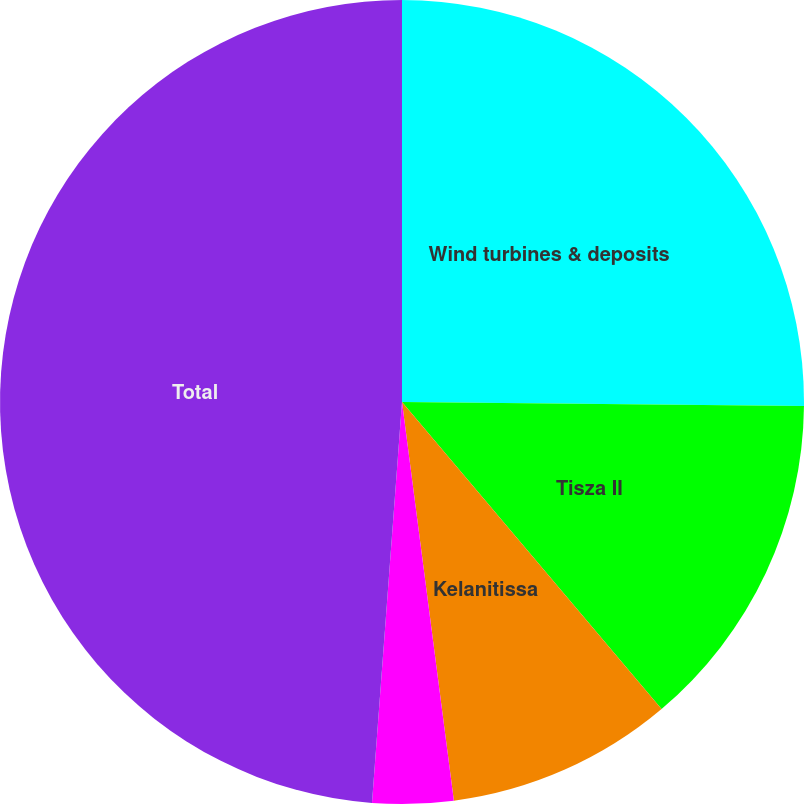Convert chart to OTSL. <chart><loc_0><loc_0><loc_500><loc_500><pie_chart><fcel>Wind turbines & deposits<fcel>Tisza II<fcel>Kelanitissa<fcel>Other<fcel>Total<nl><fcel>25.16%<fcel>13.67%<fcel>9.11%<fcel>3.25%<fcel>48.81%<nl></chart> 